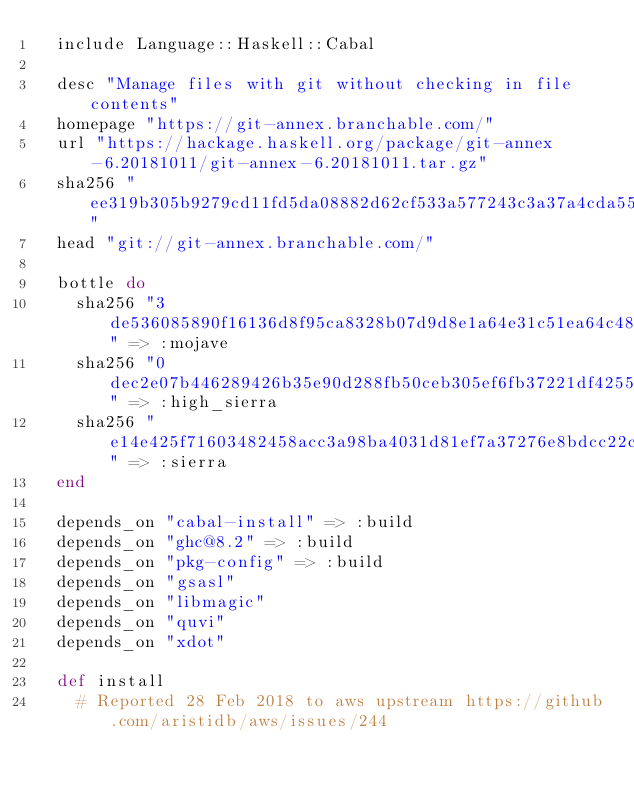Convert code to text. <code><loc_0><loc_0><loc_500><loc_500><_Ruby_>  include Language::Haskell::Cabal

  desc "Manage files with git without checking in file contents"
  homepage "https://git-annex.branchable.com/"
  url "https://hackage.haskell.org/package/git-annex-6.20181011/git-annex-6.20181011.tar.gz"
  sha256 "ee319b305b9279cd11fd5da08882d62cf533a577243c3a37a4cda55766de284c"
  head "git://git-annex.branchable.com/"

  bottle do
    sha256 "3de536085890f16136d8f95ca8328b07d9d8e1a64e31c51ea64c4866887b96eb" => :mojave
    sha256 "0dec2e07b446289426b35e90d288fb50ceb305ef6fb37221df4255e4a69d4280" => :high_sierra
    sha256 "e14e425f71603482458acc3a98ba4031d81ef7a37276e8bdcc22c28bd468e0af" => :sierra
  end

  depends_on "cabal-install" => :build
  depends_on "ghc@8.2" => :build
  depends_on "pkg-config" => :build
  depends_on "gsasl"
  depends_on "libmagic"
  depends_on "quvi"
  depends_on "xdot"

  def install
    # Reported 28 Feb 2018 to aws upstream https://github.com/aristidb/aws/issues/244</code> 